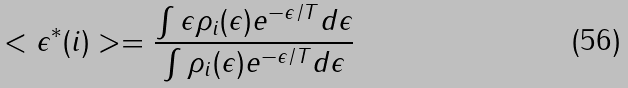Convert formula to latex. <formula><loc_0><loc_0><loc_500><loc_500>< \epsilon ^ { * } ( i ) > = \frac { \int \epsilon \rho _ { i } ( \epsilon ) e ^ { - \epsilon / T } d \epsilon } { \int \rho _ { i } ( \epsilon ) e ^ { - \epsilon / T } d \epsilon }</formula> 